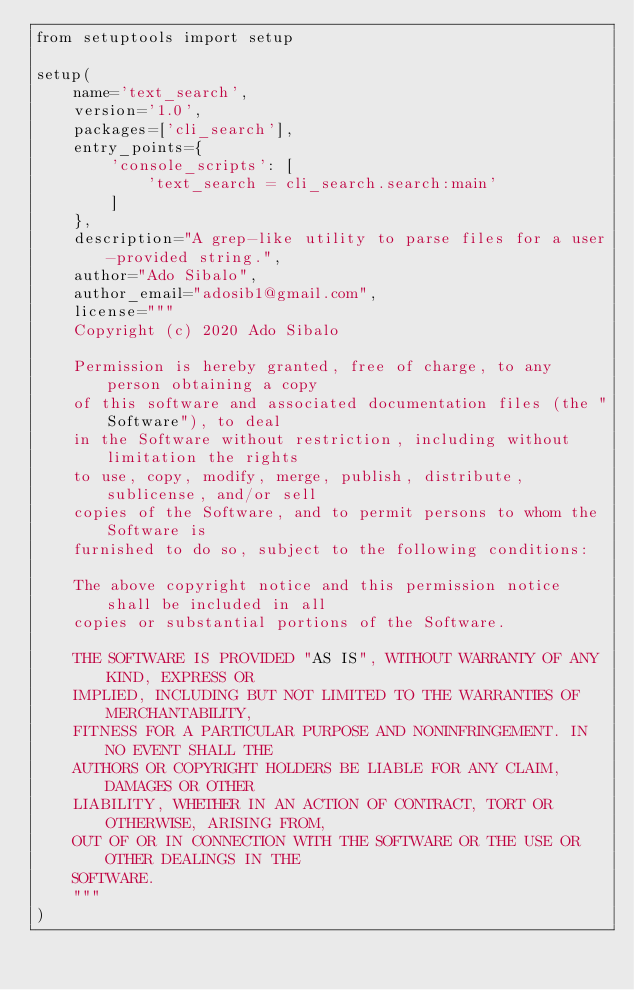<code> <loc_0><loc_0><loc_500><loc_500><_Python_>from setuptools import setup

setup(
    name='text_search',
    version='1.0',
    packages=['cli_search'],
    entry_points={
        'console_scripts': [
            'text_search = cli_search.search:main'
        ]
    },
    description="A grep-like utility to parse files for a user-provided string.",
    author="Ado Sibalo",
    author_email="adosib1@gmail.com",
    license="""
    Copyright (c) 2020 Ado Sibalo

    Permission is hereby granted, free of charge, to any person obtaining a copy
    of this software and associated documentation files (the "Software"), to deal
    in the Software without restriction, including without limitation the rights
    to use, copy, modify, merge, publish, distribute, sublicense, and/or sell
    copies of the Software, and to permit persons to whom the Software is
    furnished to do so, subject to the following conditions:

    The above copyright notice and this permission notice shall be included in all
    copies or substantial portions of the Software.

    THE SOFTWARE IS PROVIDED "AS IS", WITHOUT WARRANTY OF ANY KIND, EXPRESS OR
    IMPLIED, INCLUDING BUT NOT LIMITED TO THE WARRANTIES OF MERCHANTABILITY,
    FITNESS FOR A PARTICULAR PURPOSE AND NONINFRINGEMENT. IN NO EVENT SHALL THE
    AUTHORS OR COPYRIGHT HOLDERS BE LIABLE FOR ANY CLAIM, DAMAGES OR OTHER
    LIABILITY, WHETHER IN AN ACTION OF CONTRACT, TORT OR OTHERWISE, ARISING FROM,
    OUT OF OR IN CONNECTION WITH THE SOFTWARE OR THE USE OR OTHER DEALINGS IN THE
    SOFTWARE.
    """
)
</code> 